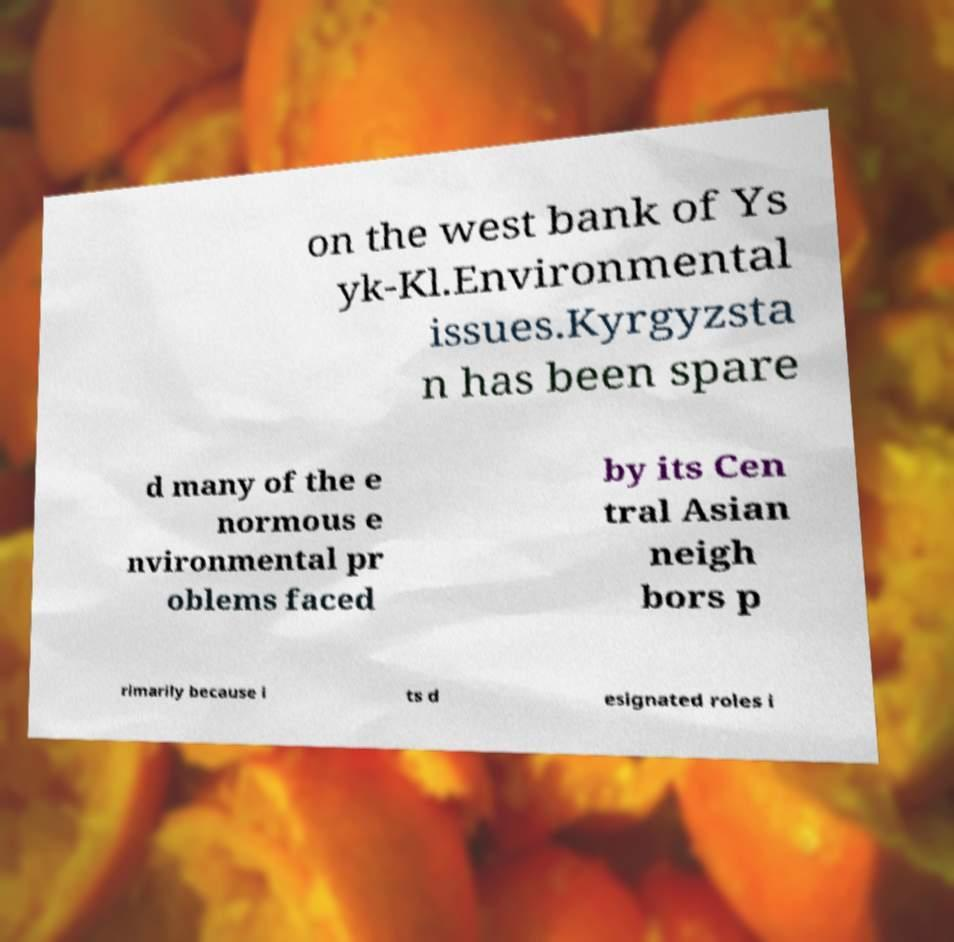There's text embedded in this image that I need extracted. Can you transcribe it verbatim? on the west bank of Ys yk-Kl.Environmental issues.Kyrgyzsta n has been spare d many of the e normous e nvironmental pr oblems faced by its Cen tral Asian neigh bors p rimarily because i ts d esignated roles i 